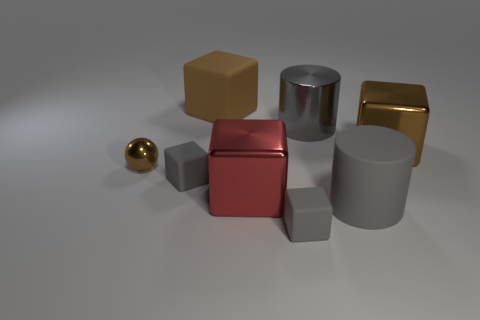Are there any large objects that are left of the rubber object behind the cylinder to the left of the big matte cylinder?
Your answer should be compact. No. Are there more tiny metal spheres than big gray matte spheres?
Keep it short and to the point. Yes. There is a large matte thing that is right of the brown matte cube; what is its color?
Your response must be concise. Gray. Is the number of metal cubes to the right of the gray shiny object greater than the number of large red shiny cylinders?
Your answer should be compact. Yes. Are the red object and the small ball made of the same material?
Offer a very short reply. Yes. How many other things are the same shape as the small brown shiny thing?
Provide a succinct answer. 0. What color is the large matte thing in front of the small brown sphere that is on the left side of the large gray cylinder that is behind the large brown metal block?
Make the answer very short. Gray. There is a small matte object in front of the red cube; is its shape the same as the gray metal object?
Provide a short and direct response. No. How many red objects are there?
Provide a succinct answer. 1. What number of matte cubes are the same size as the gray shiny cylinder?
Your answer should be compact. 1. 